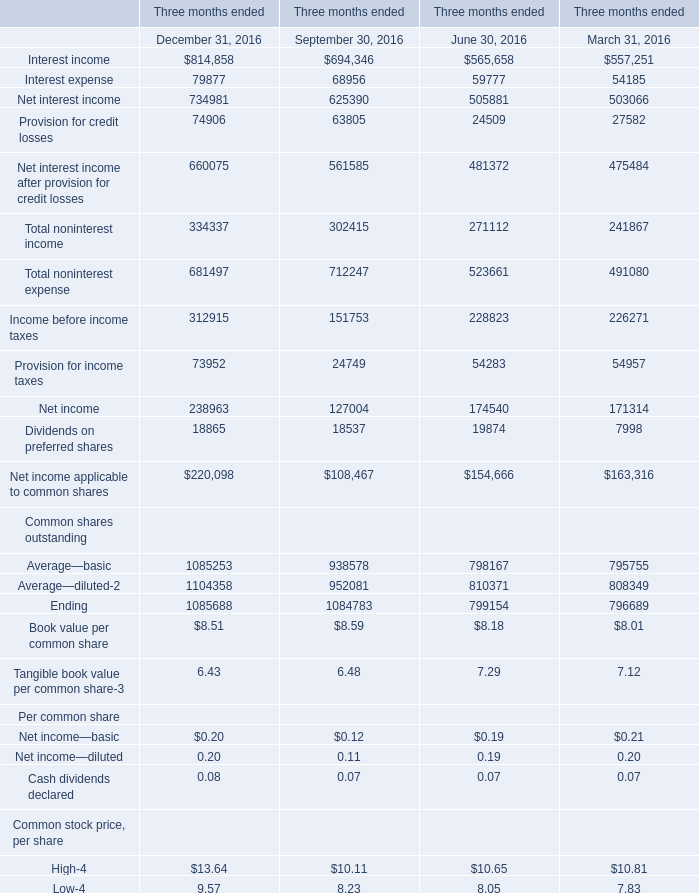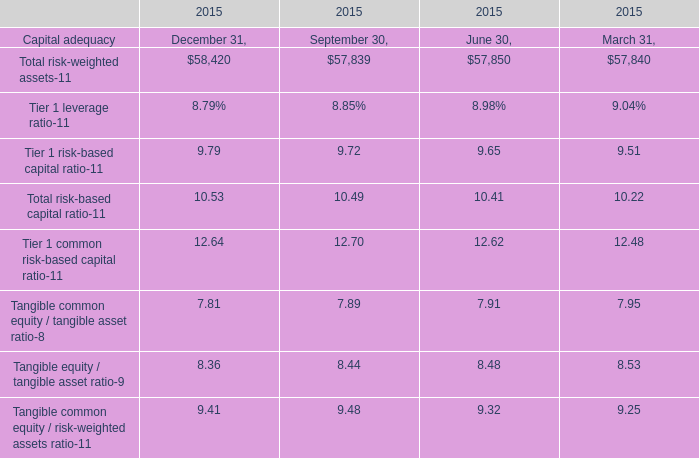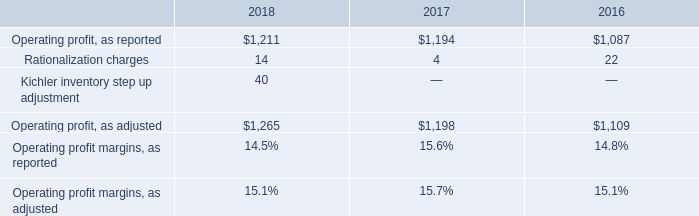What is the sum of Net interest income of Three months ended September 30, 2016, Operating profit, as adjusted of 2018, and Ending Common shares outstanding of Three months ended December 31, 2016 ? 
Computations: ((625390.0 + 1265.0) + 1085688.0)
Answer: 1712343.0. 